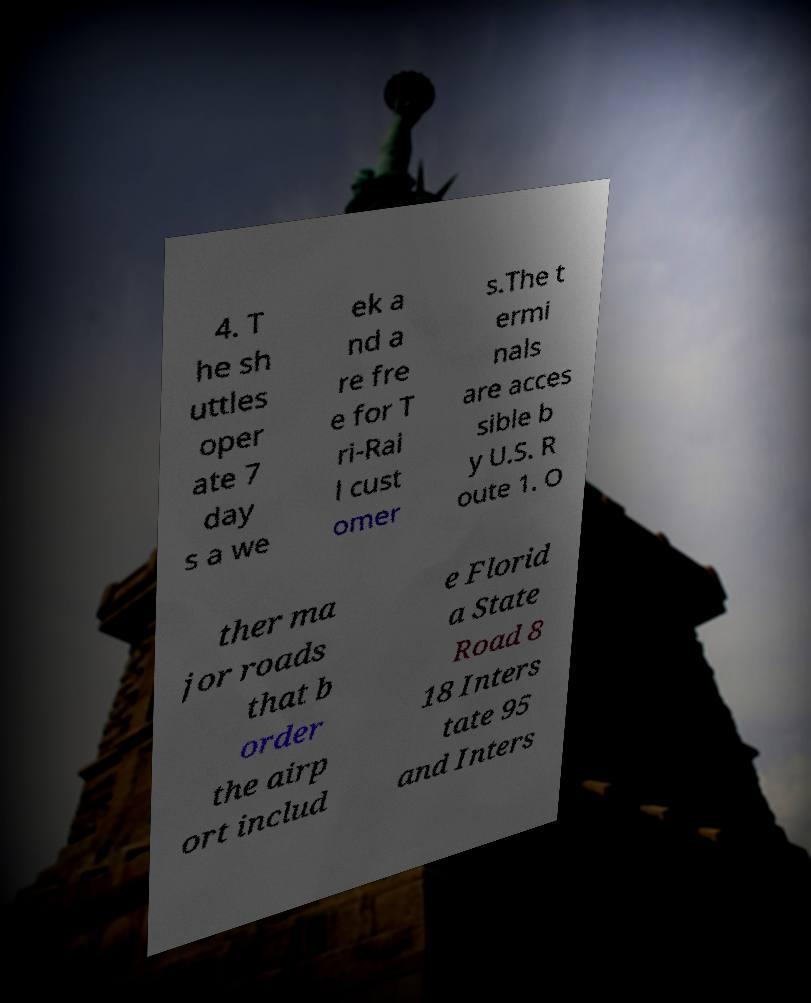Could you assist in decoding the text presented in this image and type it out clearly? 4. T he sh uttles oper ate 7 day s a we ek a nd a re fre e for T ri-Rai l cust omer s.The t ermi nals are acces sible b y U.S. R oute 1. O ther ma jor roads that b order the airp ort includ e Florid a State Road 8 18 Inters tate 95 and Inters 